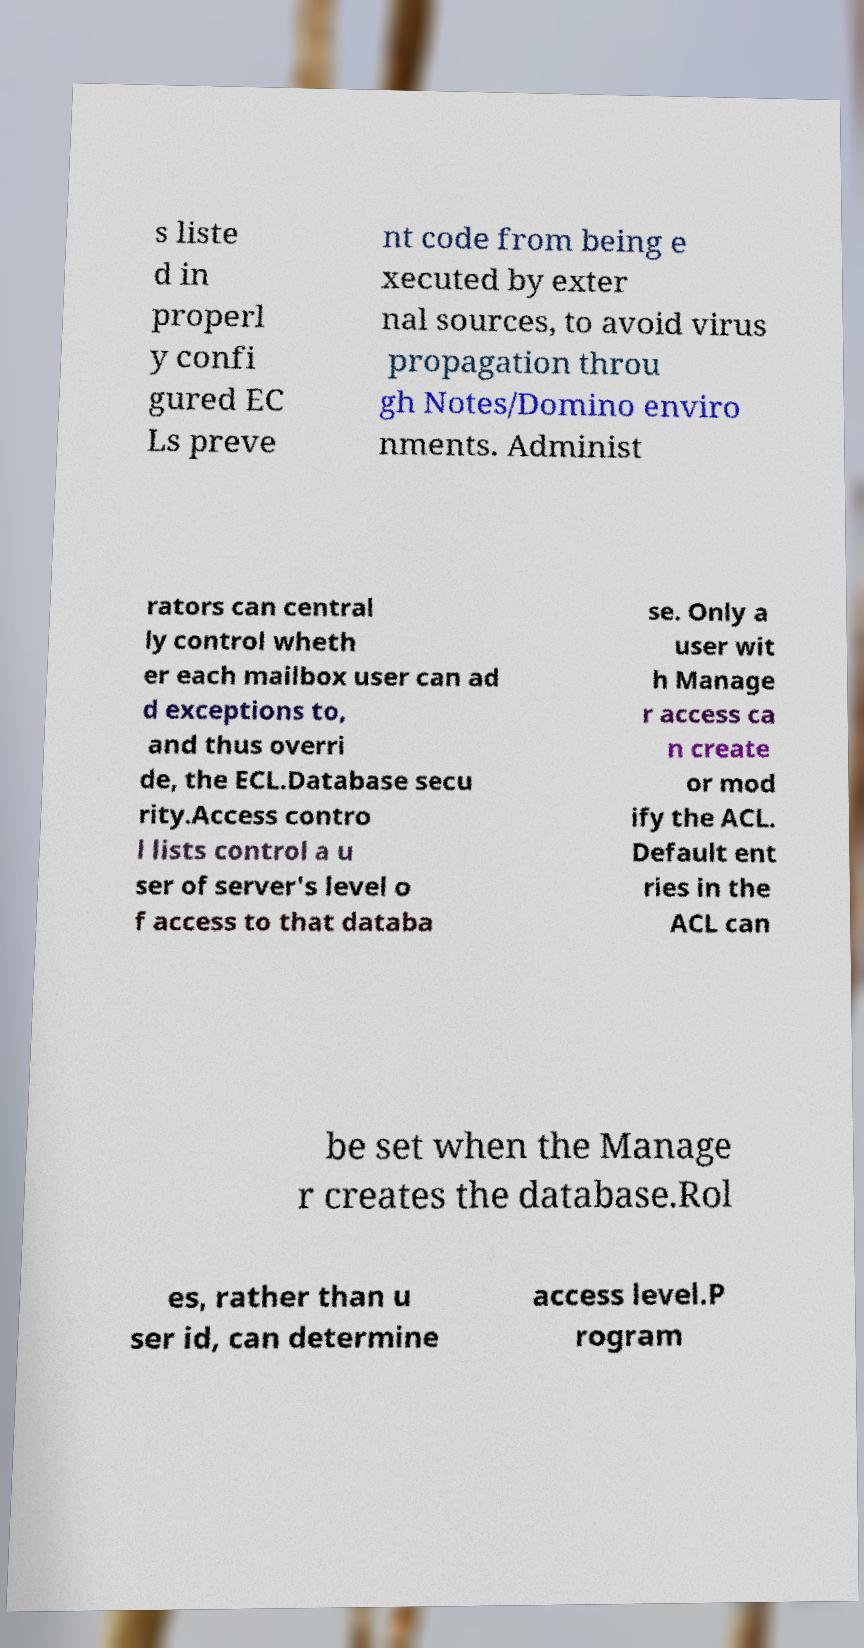Can you read and provide the text displayed in the image?This photo seems to have some interesting text. Can you extract and type it out for me? s liste d in properl y confi gured EC Ls preve nt code from being e xecuted by exter nal sources, to avoid virus propagation throu gh Notes/Domino enviro nments. Administ rators can central ly control wheth er each mailbox user can ad d exceptions to, and thus overri de, the ECL.Database secu rity.Access contro l lists control a u ser of server's level o f access to that databa se. Only a user wit h Manage r access ca n create or mod ify the ACL. Default ent ries in the ACL can be set when the Manage r creates the database.Rol es, rather than u ser id, can determine access level.P rogram 